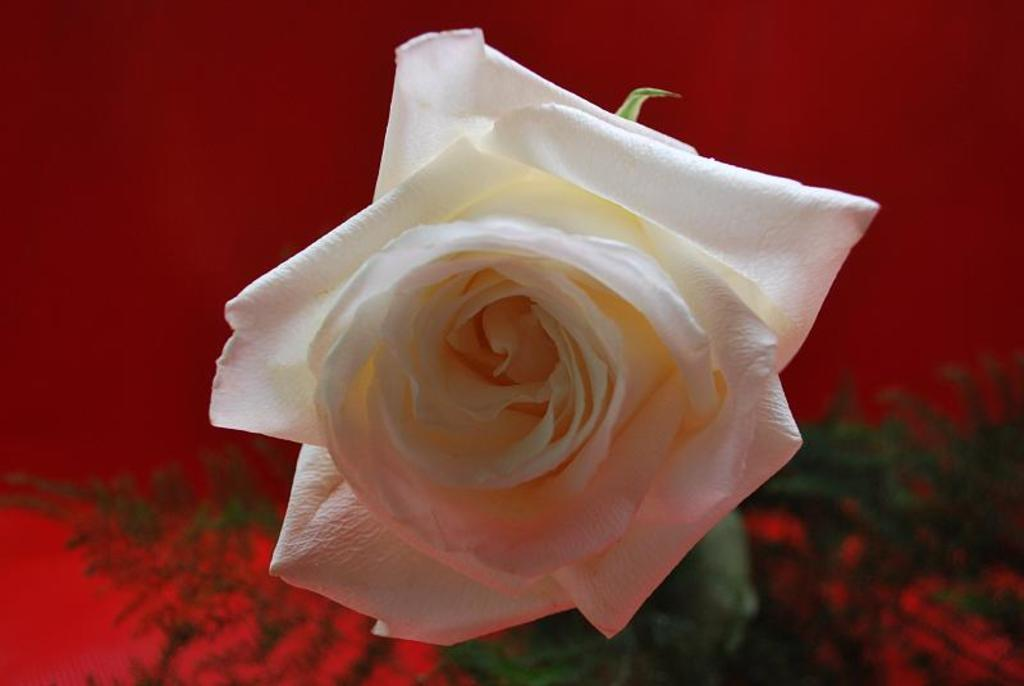What is the main subject of the image? There is a flower in the image. What can be seen in the background of the image? Planets and a red color object are visible in the background of the image. What type of sign can be seen in the image? There is no sign present in the image; it features a flower and planets in the background. What error is visible in the image? There is no error present in the image; it appears to be a representation of a flower and planets in the background. 